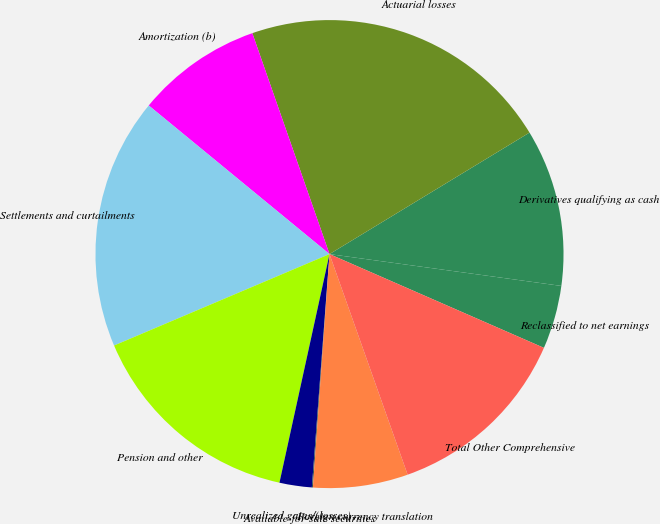Convert chart to OTSL. <chart><loc_0><loc_0><loc_500><loc_500><pie_chart><fcel>Reclassified to net earnings<fcel>Derivatives qualifying as cash<fcel>Actuarial losses<fcel>Amortization (b)<fcel>Settlements and curtailments<fcel>Pension and other<fcel>Unrealized gains/(losses)<fcel>Available-for-sale securities<fcel>Foreign currency translation<fcel>Total Other Comprehensive<nl><fcel>4.39%<fcel>10.86%<fcel>21.66%<fcel>8.7%<fcel>17.34%<fcel>15.18%<fcel>2.23%<fcel>0.07%<fcel>6.55%<fcel>13.02%<nl></chart> 